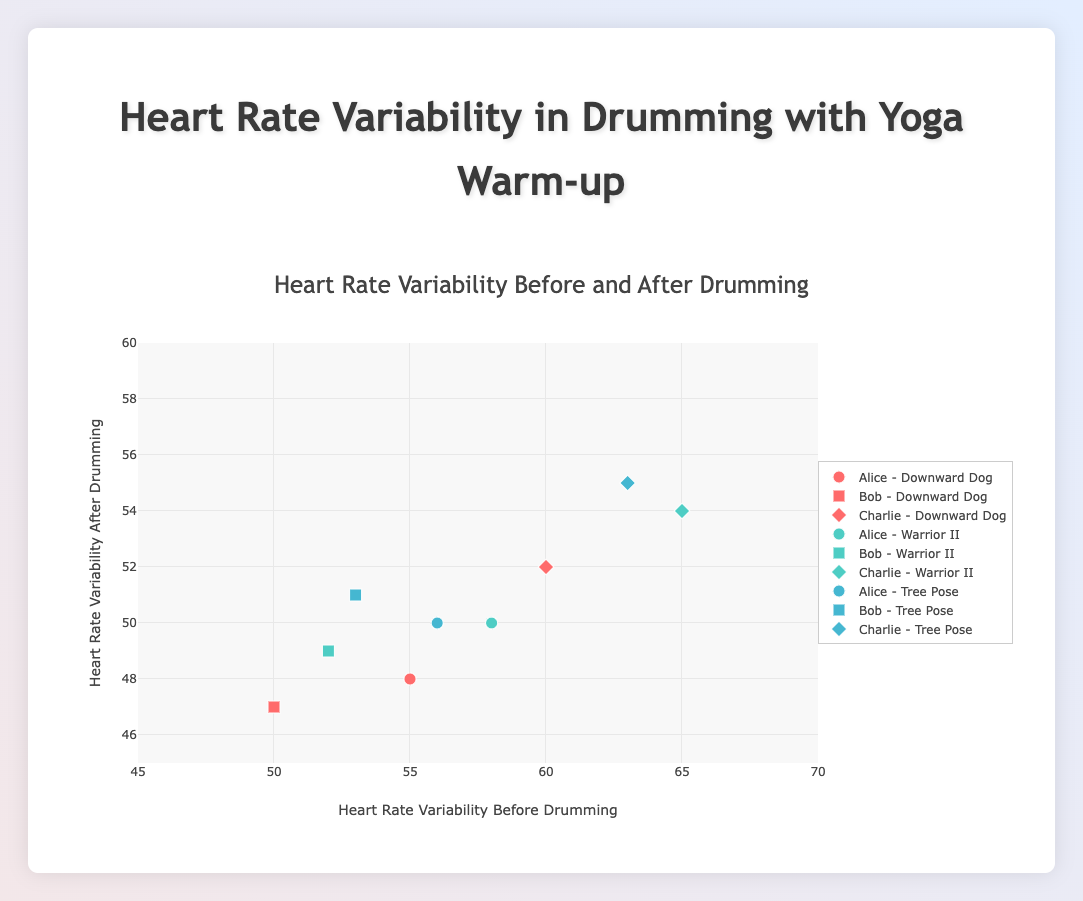How many yoga poses are represented in the plot? There are different traces in the plot color-coded and labeled by names with yoga pose-related titles. By counting the unique yoga poses, we see Downward Dog, Warrior II, and Tree Pose.
Answer: 3 What's the range of Heart Rate Variability (HRV) before drumming displayed on the x-axis? The axis range is visually defined between the minimum and maximum x-axis values evident in the figure. The x-axis range is from 45 to 70 as indicated.
Answer: 45 to 70 Which participant has the highest Heart Rate Variability after drumming when doing Warrior II? By inspecting the data points labeled for Warrior II, we see the participant names attached to each marker. The highest value on the y-axis (Heart Rate Variability after drumming) for Warrior II belongs to Charlie.
Answer: Charlie Among the participants in Downward Dog pose, who has the least reduction in Heart Rate Variability after drumming? First, we identify the participants in Downward Dog by their symbols and colors. Then, by calculating the difference between HRV before and after drumming for each, we find that Bob has the smallest HRV reduction: 50 - 47 = 3.
Answer: Bob Compare the average Heart Rate Variability before drumming for each yoga pose. Which pose has the highest average? By calculating the average HRV before drumming for each pose: 
- Downward Dog: (55 + 50 + 60)/3 = 55
- Warrior II: (58 + 52 + 65)/3 = 58.33
- Tree Pose: (56 + 53 + 63)/3 = 57.33
Warrior II has the highest average HRV before drumming.
Answer: Warrior II What's the relationship between Heart Rate Variability after drumming for Tree Pose and Downward Dog? By checking the y-axis values for Tree Pose and Downward Dog, it appears that Tree Pose HRV after drumming is consistently higher than Downward Dog HRV after drumming for respective participants.
Answer: Tree Pose > Downward Dog If the aim is to minimize the decrease in Heart Rate Variability after drumming, which yoga pose seems most effective? Comparing the decreases for each pose, we find that the smallest reductions occur more frequently in Tree Pose (e.g., Alice: 56-50=6, Bob: 53-51=2, Charlie: 63-55=8) suggesting the smallest reduction in HRV post-drumming.
Answer: Tree Pose Which participant shows a consistent trend of specific Heart Rate Variability changes across all yoga poses before and after drumming? Analyzing each participant's HRV changes:
- Alice: decreases 55 to 48, 58 to 50, 56 to 50 
- Bob: decreases 50 to 47, 52 to 49, 53 to 51 
- Charlie: decreases 60 to 52, 65 to 54, 63 to 55
Bob shows consistent minor decreases across all poses.
Answer: Bob Looking at the plot distribution, how do the spreads of Heart Rate Variability before and after drumming compare? The spread can be determined by observing data points' distances from the central values along the x-axis (before) and y-axis (after). The spreads for HRV before drumming seem larger compared to HRV after drumming, evident from condensed y-axis data points.
Answer: Before > After 